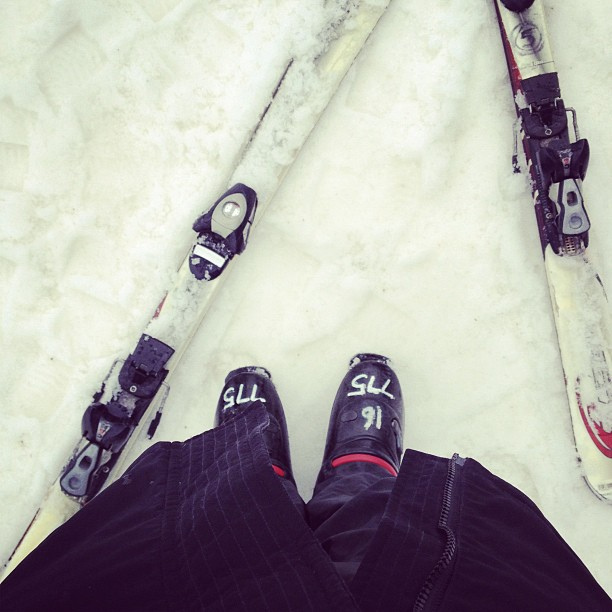Read all the text in this image. 91 775 775 